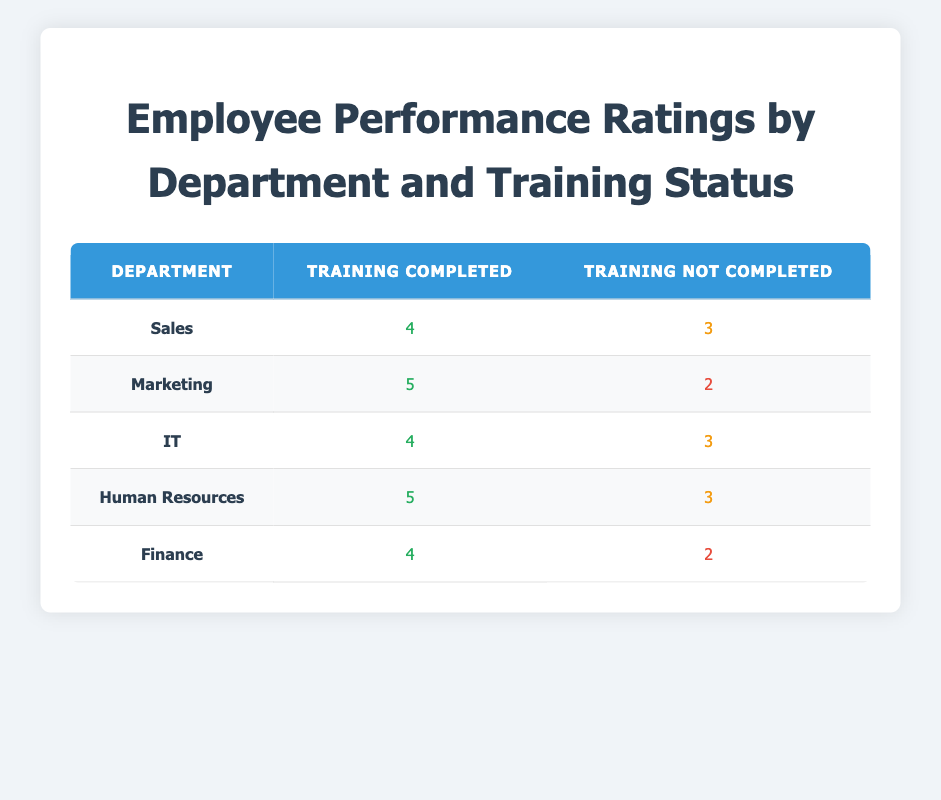What is the performance rating for the Marketing department with training completed? The table shows that the Marketing department has a performance rating of 5 for employees who completed training.
Answer: 5 Which department has the lowest performance rating for employees who did not complete training? By examining the table, the department with the lowest performance rating for those who did not complete training is Marketing, with a rating of 2.
Answer: Marketing What is the average performance rating for employees who completed training across all departments? To find the average, we add all the ratings for completed training: (4 + 5 + 4 + 5 + 4) = 22. There are five departments, so the average is 22/5 = 4.4.
Answer: 4.4 Is it true that all departments have a higher performance rating for those who completed training compared to those who did not? Yes, upon checking each row in the table, every department shows a higher performance rating for training completed versus training not completed.
Answer: Yes Which department has the highest overall performance rating for employees who completed training, and what is that rating? By comparing the ratings for completed training, we see that Marketing has the highest rating of 5.
Answer: Marketing, 5 What is the difference between the highest and lowest performance ratings for employees with training not completed? The highest rating for not completed training is 3 (Sales, IT, Human Resources) and the lowest is 2 (Marketing, Finance). The difference is 3 - 2 = 1.
Answer: 1 What is the performance rating for the IT department with training completed? The IT department's performance rating for training completed is 4, as shown in the table.
Answer: 4 How many departments have a performance rating of 3 or less for employees who did not complete training? The departments with 3 or less ratings for not completed training are Marketing and Finance, so there are two departments.
Answer: 2 What is the overall performance rating of employees in the Finance department? The Finance department has a performance rating of 4 for training completed and 2 for training not completed.
Answer: 4, 2 